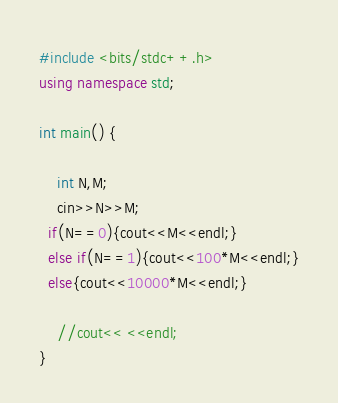Convert code to text. <code><loc_0><loc_0><loc_500><loc_500><_C++_>#include <bits/stdc++.h>
using namespace std;

int main() {

	int N,M;
	cin>>N>>M;
  if(N==0){cout<<M<<endl;}
  else if(N==1){cout<<100*M<<endl;}
  else{cout<<10000*M<<endl;}
	
	//cout<< <<endl;
}
</code> 